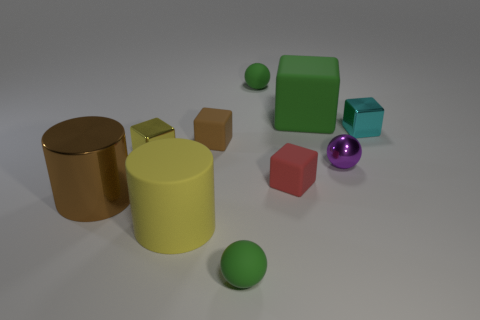Is the number of big rubber cylinders that are left of the big shiny cylinder the same as the number of big blocks that are in front of the yellow shiny cube?
Your answer should be compact. Yes. There is another object that is the same shape as the large yellow matte thing; what material is it?
Your response must be concise. Metal. What shape is the green matte thing that is in front of the cyan thing on the right side of the large cylinder that is in front of the shiny cylinder?
Offer a very short reply. Sphere. Are there more tiny red matte objects that are behind the big green block than blue cubes?
Make the answer very short. No. There is a tiny green object in front of the small yellow block; is its shape the same as the small red rubber thing?
Give a very brief answer. No. There is a small green sphere that is behind the large yellow cylinder; what is it made of?
Your answer should be very brief. Rubber. What number of purple metallic things are the same shape as the big brown object?
Your response must be concise. 0. There is a large thing that is behind the tiny red thing that is in front of the tiny purple ball; what is it made of?
Your response must be concise. Rubber. Are there any large green blocks made of the same material as the big brown object?
Your answer should be very brief. No. There is a yellow shiny thing; what shape is it?
Provide a short and direct response. Cube. 